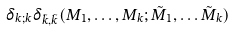Convert formula to latex. <formula><loc_0><loc_0><loc_500><loc_500>\delta _ { k ; k } \delta _ { \tilde { k } , \tilde { k } } ( M _ { 1 } , \dots , M _ { k } ; \tilde { M } _ { 1 } , \dots \tilde { M } _ { k } )</formula> 